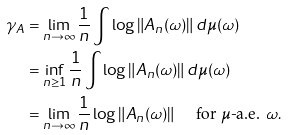Convert formula to latex. <formula><loc_0><loc_0><loc_500><loc_500>\gamma _ { A } & = \lim _ { n \to \infty } \frac { 1 } { n } \int \log \| A _ { n } ( \omega ) \| \, d \mu ( \omega ) \\ & = \inf _ { n \geq 1 } \frac { 1 } { n } \int \log \| A _ { n } ( \omega ) \| \, d \mu ( \omega ) \\ & = \lim _ { n \to \infty } \frac { 1 } { n } \log \| A _ { n } ( \omega ) \| \quad \text { for $\mu$-a.e. } \omega .</formula> 